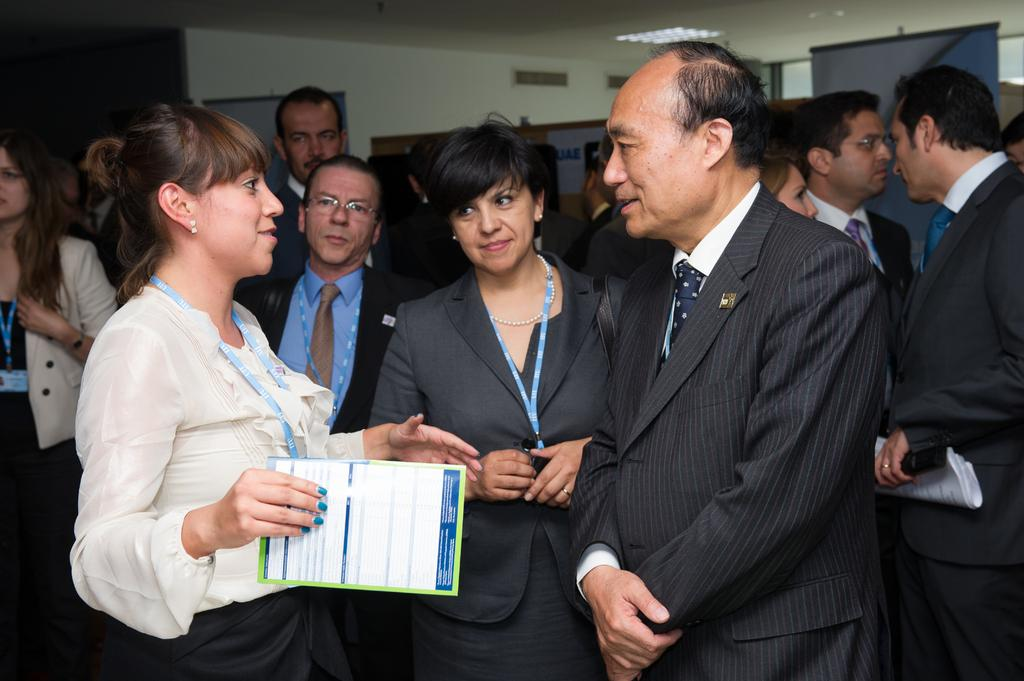What can be seen in the foreground of the picture? There are people standing in the foreground of the picture. What are the people wearing? Many of the people are wearing suits. What is visible in the background of the picture? There are boards, a door, lights, and a window in the background of the picture. How does the skirt in the image test the strength of the boards? There is no skirt present in the image, and therefore no such test can be observed. 